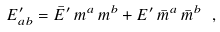<formula> <loc_0><loc_0><loc_500><loc_500>E ^ { \prime } _ { a b } = \bar { E } ^ { \prime } \, m ^ { a } \, m ^ { b } + E ^ { \prime } \, \bar { m } ^ { a } \, \bar { m } ^ { b } \ ,</formula> 